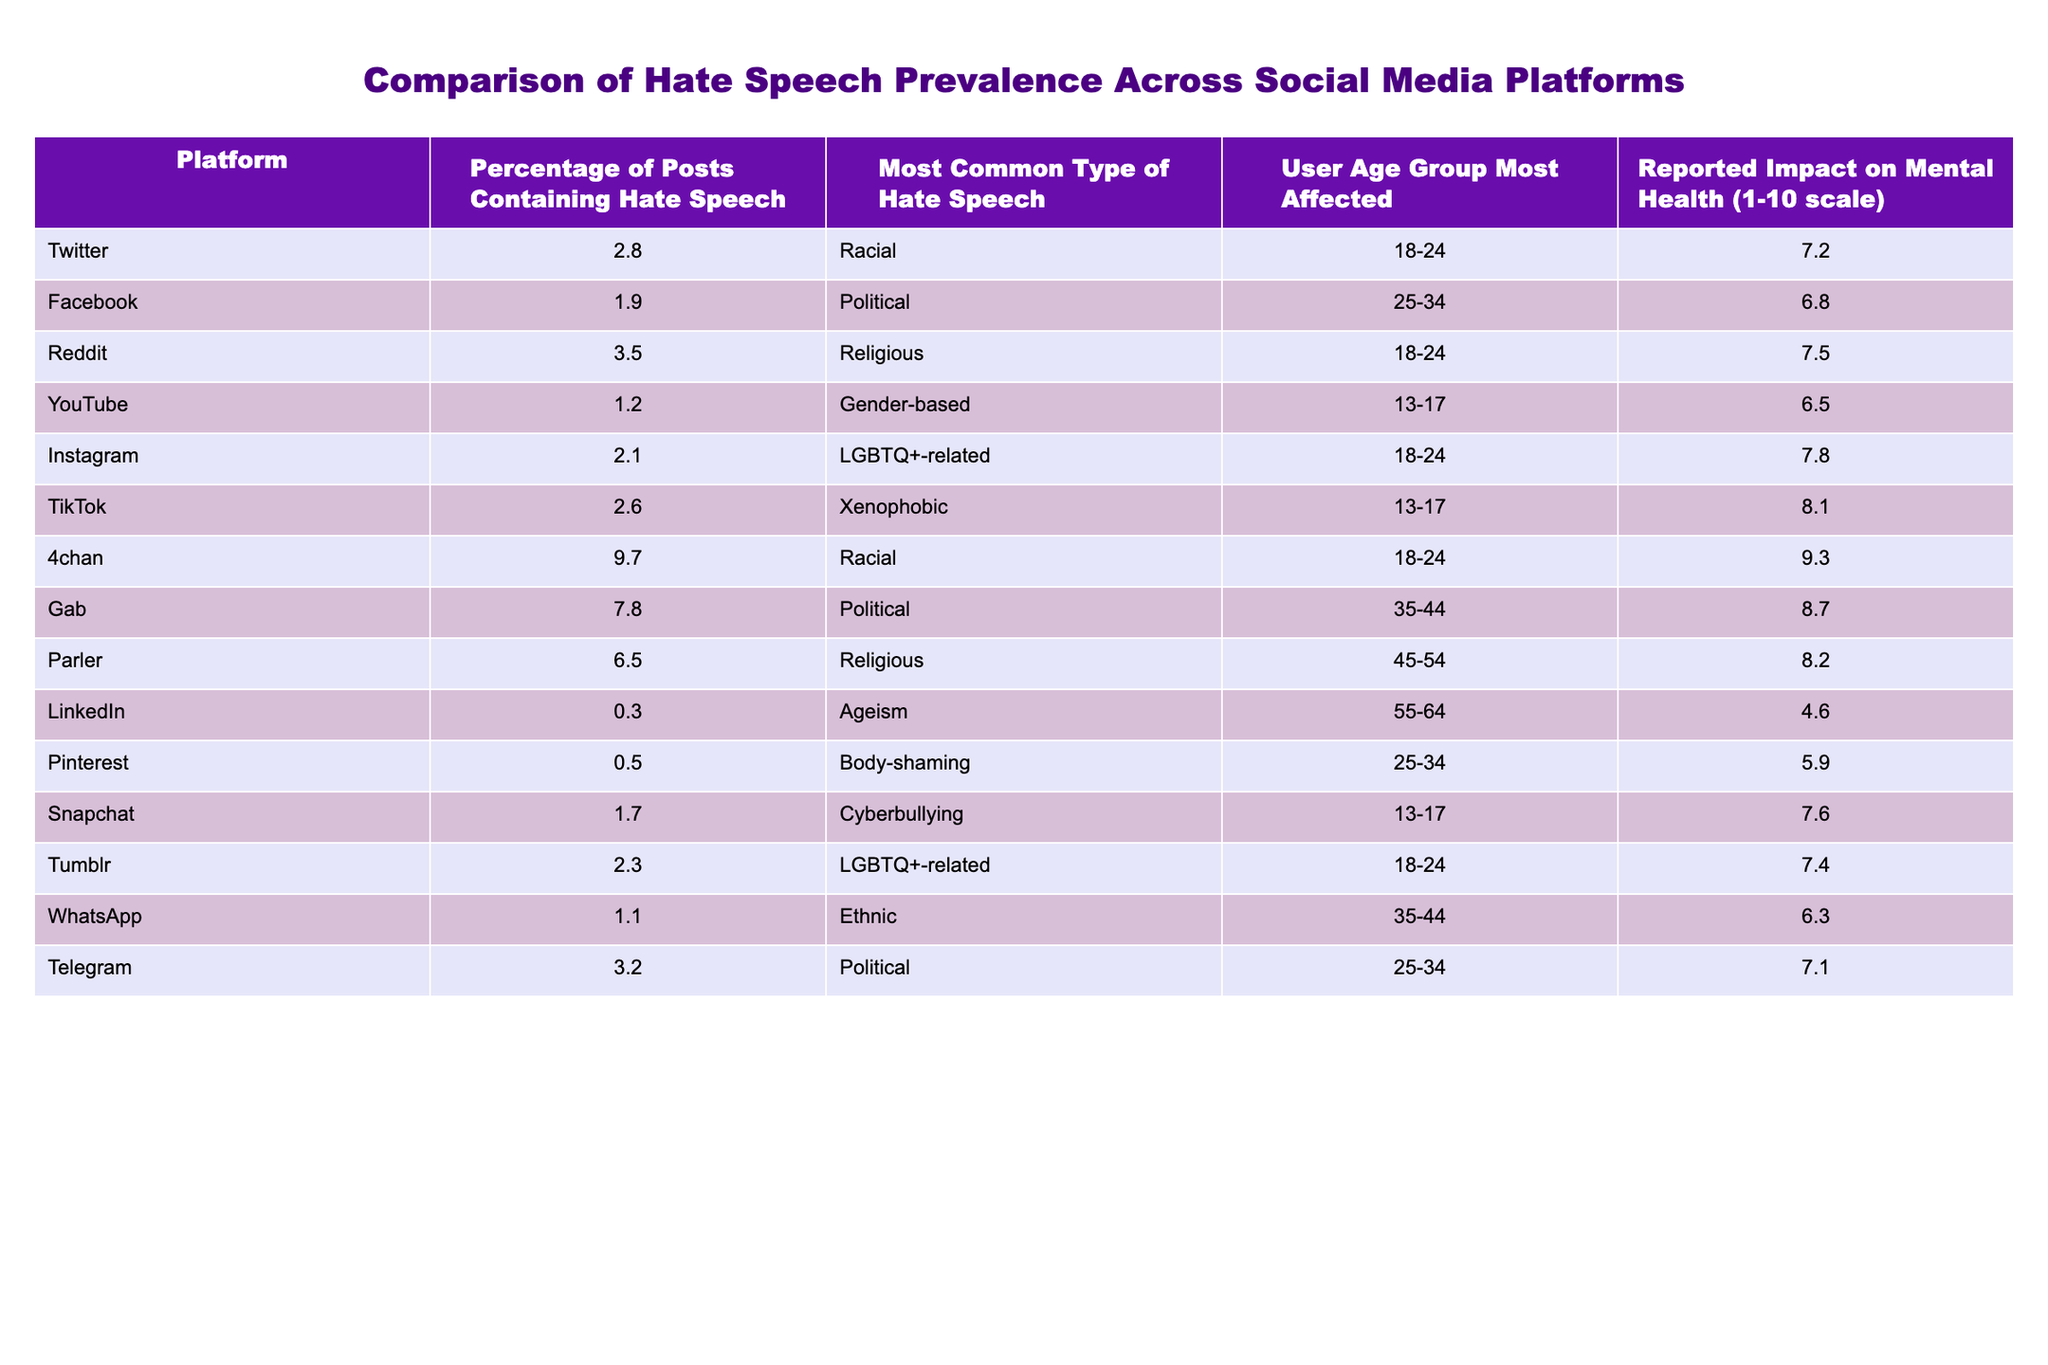What is the highest percentage of posts containing hate speech? The table shows various platforms and their corresponding percentages. The highest percentage listed is 9.7 for 4chan.
Answer: 9.7 Which platform has the lowest percentage of hate speech? By examining the table, LinkedIn has the lowest percentage of posts containing hate speech at 0.3.
Answer: 0.3 What type of hate speech is most common on Reddit? The table clearly states that the most common type of hate speech on Reddit is religious.
Answer: Religious What is the reported impact on mental health for TikTok users? Looking at the table, the reported impact on mental health for TikTok users is 8.1 on a scale of 1 to 10.
Answer: 8.1 How many platforms have a percentage of hate speech greater than 5%? By counting the percentages in the table, there are 3 platforms (4chan, Gab, and Parler) with percentages greater than 5%.
Answer: 3 What's the average reported impact on mental health for all platforms? To find the average, I sum all the reported impacts: (7.2 + 6.8 + 7.5 + 6.5 + 7.8 + 8.1 + 9.3 + 8.7 + 8.2 + 4.6 + 5.9 + 7.6 + 7.4 + 6.3 + 7.1) = 108.6, and then divide by 15 platforms, resulting in an average impact of 7.24.
Answer: 7.24 Does the age group 18-24 experience the most severe reported impact on mental health among others? The maximum reported impact is 9.3 for 4chan (age 18-24), indicating that this age group has the most severe impact compared to others listed.
Answer: Yes Which platform has the most common type of hate speech related to LGBTQ+ issues and what is its percentage? The table indicates that Instagram has the most common type of hate speech related to LGBTQ+ issues, with a percentage of 2.1.
Answer: 2.1 What is the difference in mental health impact between users of Gab and Facebook? By comparing the two values, Gab has an impact of 8.7 and Facebook has 6.8, so the difference is 8.7 - 6.8 = 1.9.
Answer: 1.9 What percentage of posts on social media platforms relate to xenophobic hate speech? The only platform with xenophobic hate speech indicated is TikTok, which has a percentage of 2.6.
Answer: 2.6 Is the type of hate speech that is most common on LinkedIn different from that on Snapchat? According to the table, the type of hate speech most common on LinkedIn is ageism, while on Snapchat it is cyberbullying, thus they are different.
Answer: Yes 